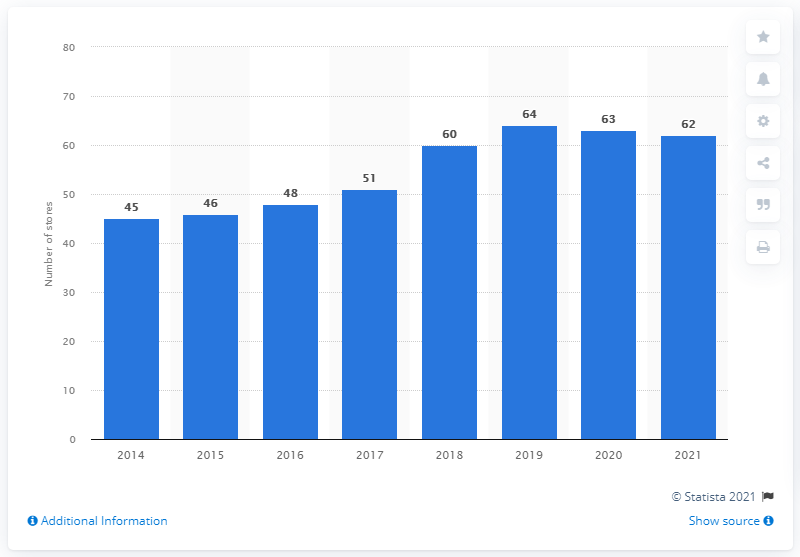Specify some key components in this picture. As of January 2021, Lululemon operated a total of 62 stores in Canada. 